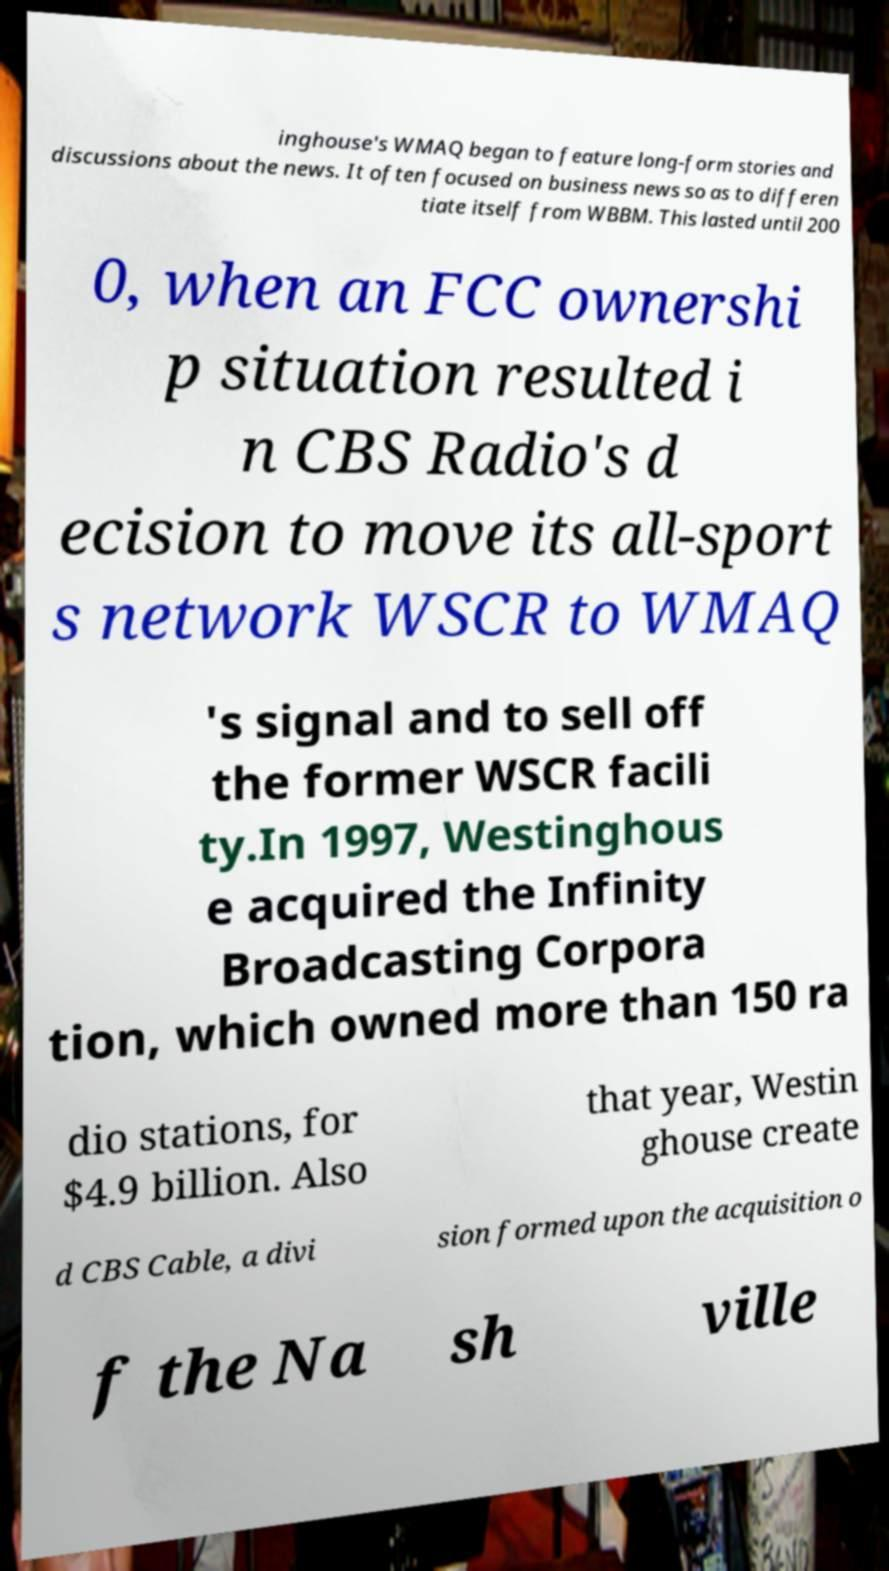Could you assist in decoding the text presented in this image and type it out clearly? inghouse's WMAQ began to feature long-form stories and discussions about the news. It often focused on business news so as to differen tiate itself from WBBM. This lasted until 200 0, when an FCC ownershi p situation resulted i n CBS Radio's d ecision to move its all-sport s network WSCR to WMAQ 's signal and to sell off the former WSCR facili ty.In 1997, Westinghous e acquired the Infinity Broadcasting Corpora tion, which owned more than 150 ra dio stations, for $4.9 billion. Also that year, Westin ghouse create d CBS Cable, a divi sion formed upon the acquisition o f the Na sh ville 